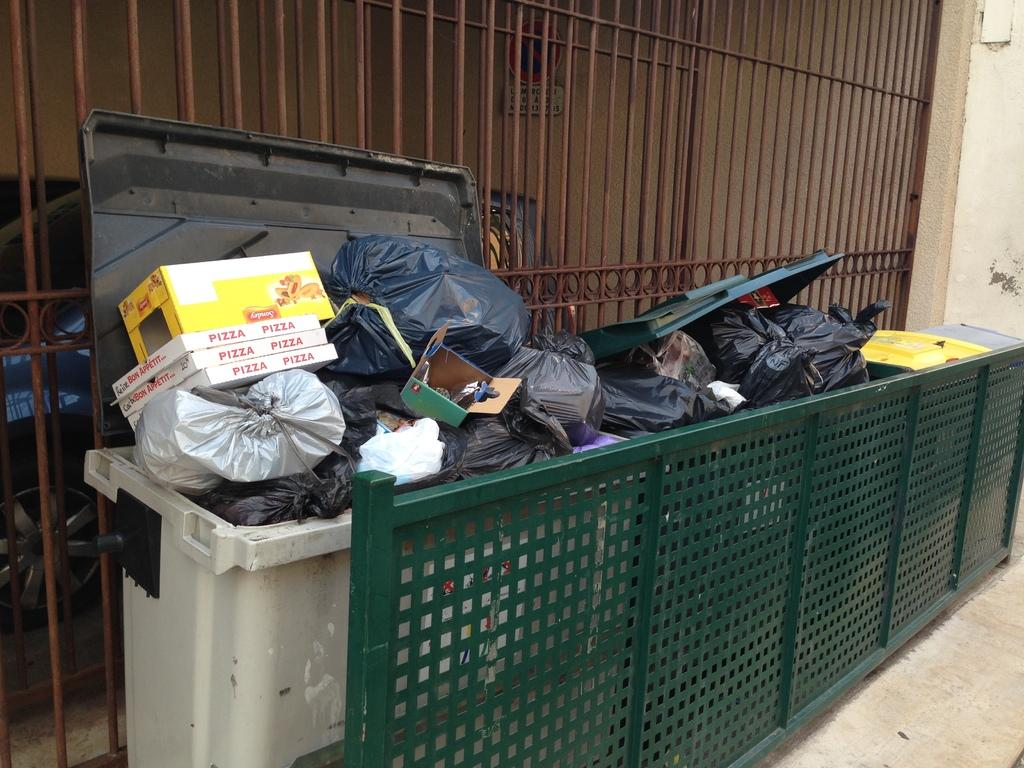<image>
Render a clear and concise summary of the photo. Trash bins sit out side with boxes piled on one that say Pizza on the side. 